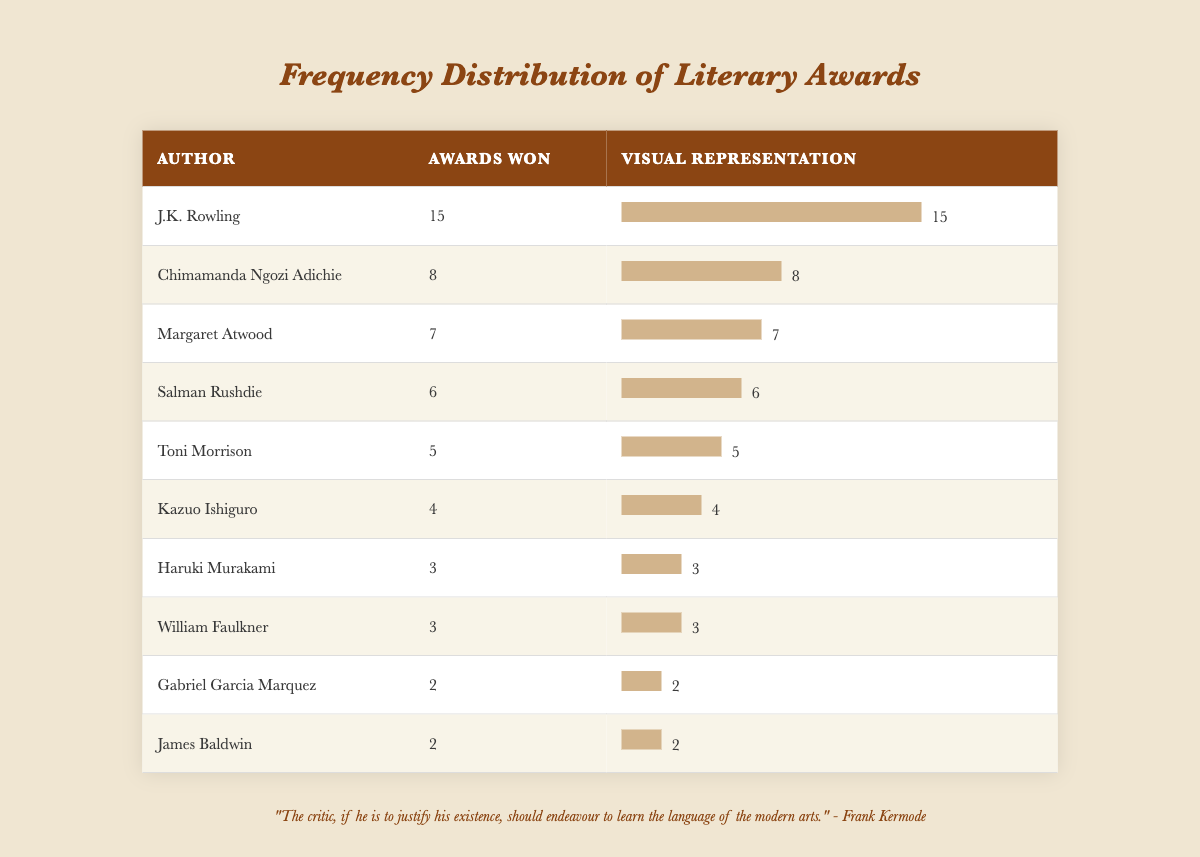What is the maximum number of awards won by an author in this table? The table shows that J.K. Rowling has won 15 awards, which is the highest number in the list.
Answer: 15 Who won more awards, Toni Morrison or Haruki Murakami? Toni Morrison has won 5 awards while Haruki Murakami has won 3 awards, so Toni Morrison won more.
Answer: Toni Morrison What is the total number of awards won by all authors listed? To find the total, add all the awards: 5 + 6 + 4 + 7 + 15 + 2 + 3 + 8 + 2 + 3 = 55.
Answer: 55 Is it true that Gabriel Garcia Marquez won more awards than Kazuo Ishiguro? Gabriel Garcia Marquez won 2 awards, while Kazuo Ishiguro won 4 awards, so the statement is false.
Answer: No What is the average number of awards won by the authors listed in the table? The total number of awards is 55, and there are 10 authors, so the average is 55/10 = 5.5.
Answer: 5.5 Which author won the second highest number of awards? J.K. Rowling won the highest with 15, and the second highest is Chimamanda Ngozi Adichie, with 8 awards.
Answer: Chimamanda Ngozi Adichie How many authors won three or more awards? The authors with three or more awards are J.K. Rowling, Chimamanda Ngozi Adichie, Margaret Atwood, Salman Rushdie, Toni Morrison, Kazuo Ishiguro, Haruki Murakami, and William Faulkner—totaling 8 authors.
Answer: 8 What is the difference in the number of awards won between the author with the most awards and the author with the fewest awards? J.K. Rowling has the most with 15 awards, and Gabriel Garcia Marquez and James Baldwin both have the least with 2 awards. The difference is 15 - 2 = 13.
Answer: 13 